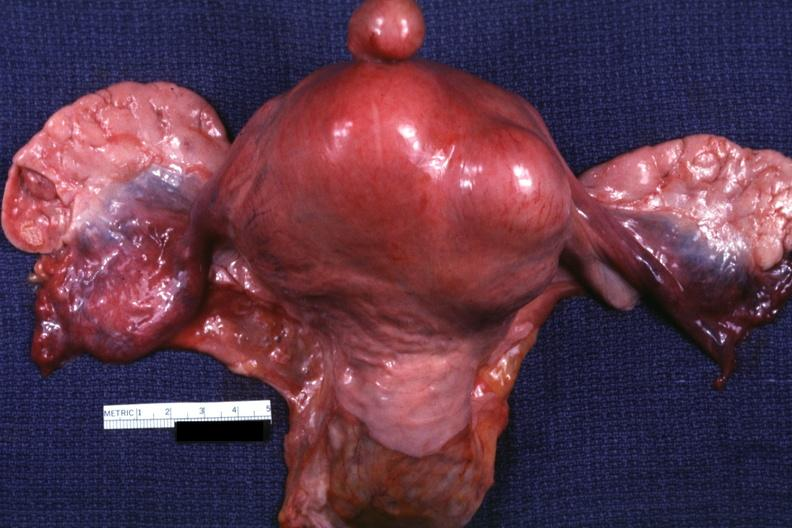s female reproductive present?
Answer the question using a single word or phrase. Yes 